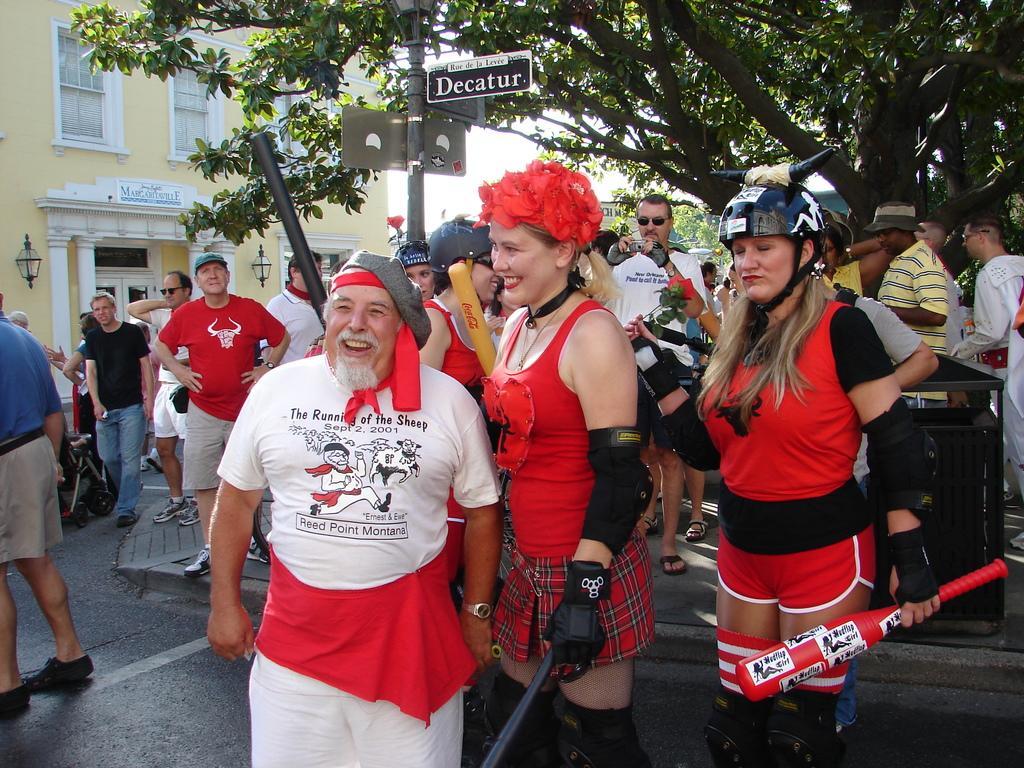How would you summarize this image in a sentence or two? In this image in the front there are group of persons standing. In the front there is a man standing and smiling and in the background there are trees, there is a building and there is a pole and in the front there is a woman standing and smiling wearing a red colour dress and holding an object which is black in colour in her hand. 